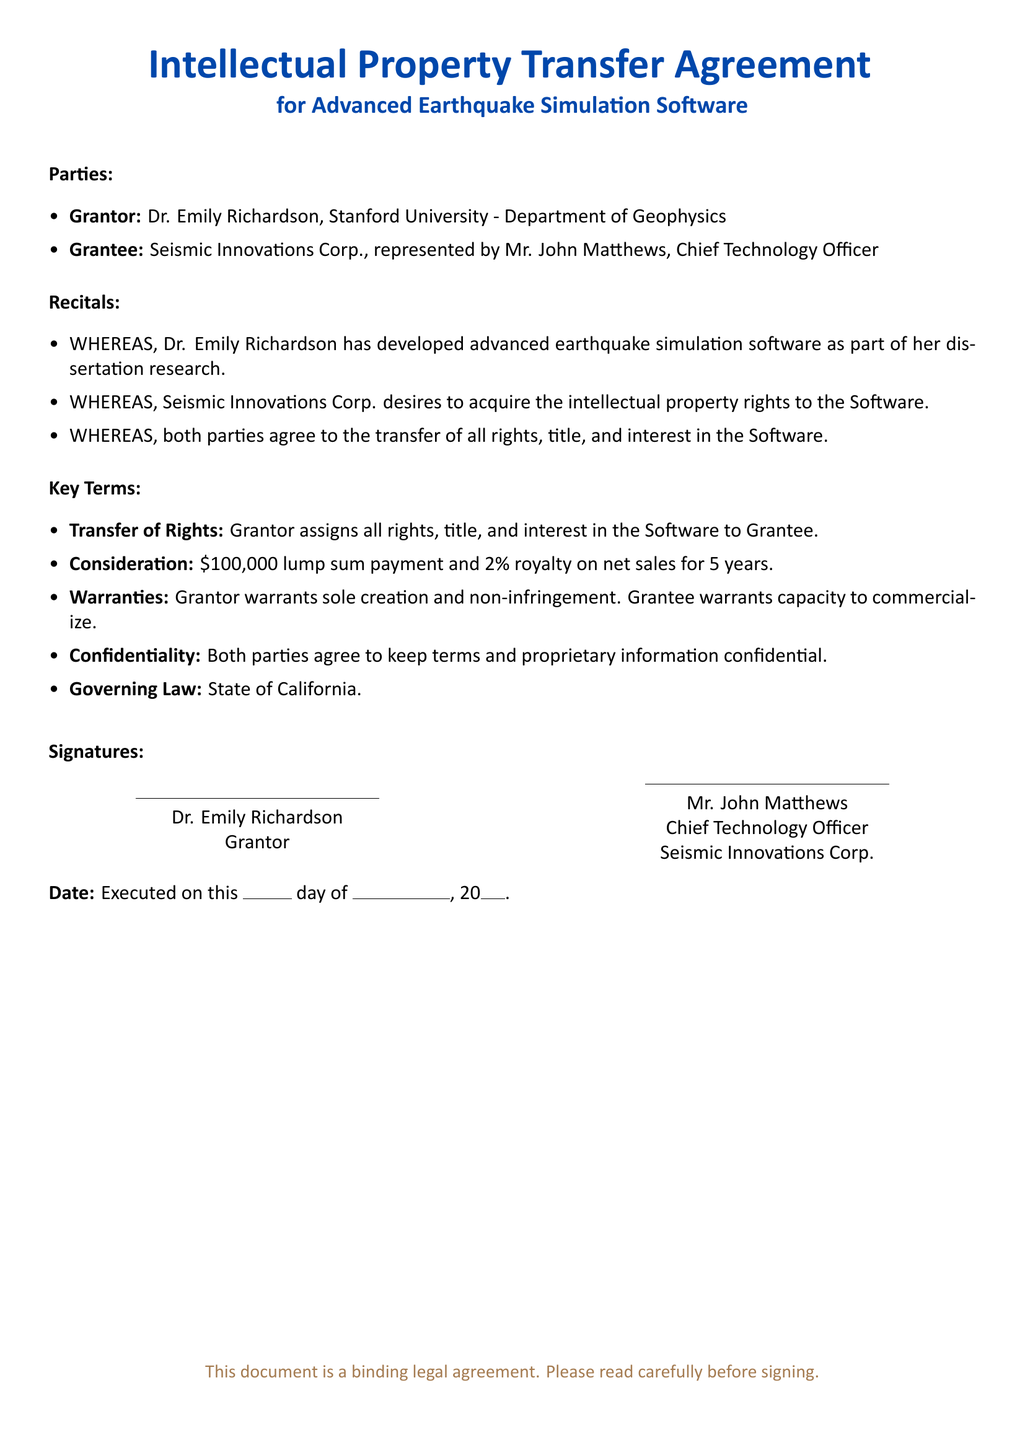what is the name of the grantor? The grantor is identified as Dr. Emily Richardson in the document.
Answer: Dr. Emily Richardson who is the grantee? The grantee is Seismic Innovations Corp., represented by Mr. John Matthews.
Answer: Seismic Innovations Corp what is the consideration amount for the transfer? The document states that the consideration amount is a lump sum payment and royalty for a specific duration.
Answer: $100,000 how long is the royalty period? The royalty period is mentioned in terms of years in the document.
Answer: 5 years what warranty does the grantor provide? The grantor provides a warranty regarding the creation and rights associated with the software.
Answer: Sole creation and non-infringement under which state's law is the agreement governed? The governing law for the agreement is specified as a state in the document.
Answer: California what percentage royalty is included in the agreement? The percentage royalty on net sales is outlined in the key terms of the document.
Answer: 2% who must keep terms and proprietary information confidential? The document specifies that both parties are obligated to maintain confidentiality.
Answer: Both parties who signed on behalf of Seismic Innovations Corp.? The representative for Seismic Innovations Corp. as stated in the document is Mr. John Matthews.
Answer: Mr. John Matthews 